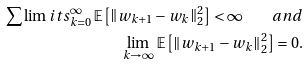<formula> <loc_0><loc_0><loc_500><loc_500>\sum \lim i t s _ { k = 0 } ^ { \infty } \, \mathbb { E } \left [ \left \| w _ { k + 1 } - w _ { k } \right \| _ { 2 } ^ { 2 } \right ] < \infty \quad a n d \\ \lim _ { k \rightarrow \infty } \, \mathbb { E } \left [ \left \| { w } _ { k + 1 } - { w } _ { k } \right \| _ { 2 } ^ { 2 } \right ] = 0 .</formula> 